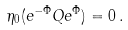<formula> <loc_0><loc_0><loc_500><loc_500>\eta _ { 0 } ( e ^ { - \Phi } Q e ^ { \Phi } ) = 0 \, .</formula> 